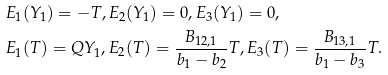<formula> <loc_0><loc_0><loc_500><loc_500>& E _ { 1 } ( Y _ { 1 } ) = - T , E _ { 2 } ( Y _ { 1 } ) = 0 , E _ { 3 } ( Y _ { 1 } ) = 0 , \\ & E _ { 1 } ( T ) = Q Y _ { 1 } , E _ { 2 } ( T ) = \frac { B _ { 1 2 , 1 } } { b _ { 1 } - b _ { 2 } } T , E _ { 3 } ( T ) = \frac { B _ { 1 3 , 1 } } { b _ { 1 } - b _ { 3 } } T .</formula> 